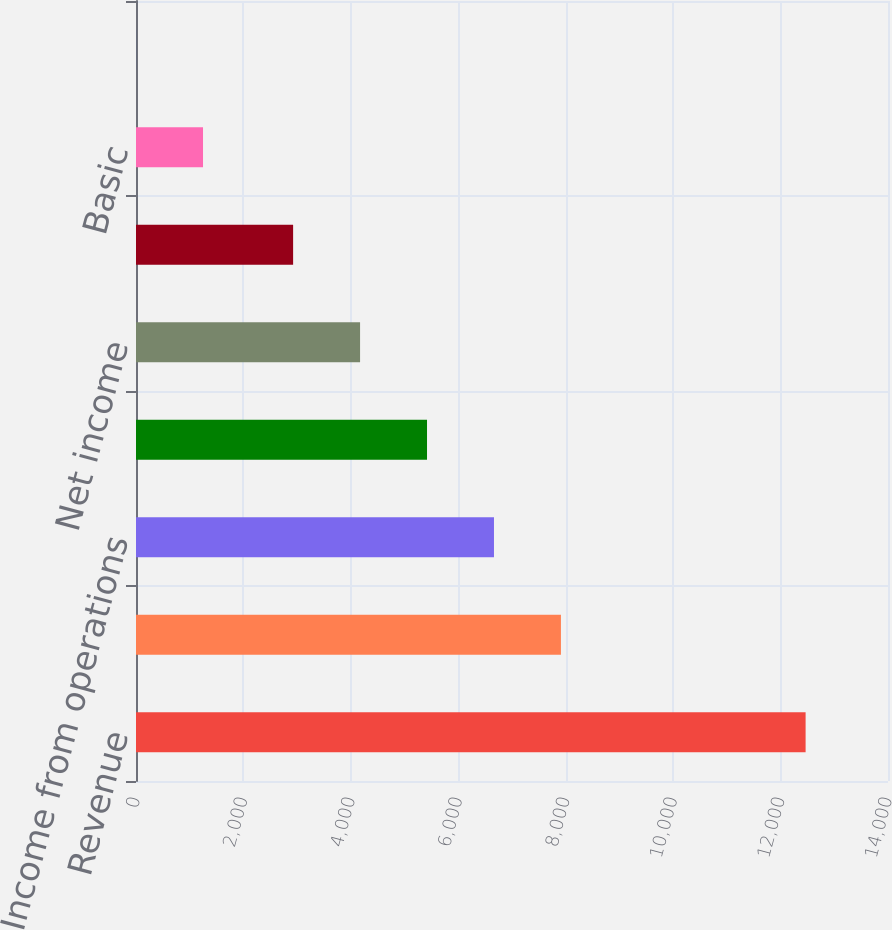Convert chart. <chart><loc_0><loc_0><loc_500><loc_500><bar_chart><fcel>Revenue<fcel>Total costs and expenses (2)<fcel>Income from operations<fcel>Income before provision for<fcel>Net income<fcel>Net income attributable to<fcel>Basic<fcel>Diluted<nl><fcel>12466<fcel>7910.96<fcel>6664.47<fcel>5417.98<fcel>4171.49<fcel>2925<fcel>1247.59<fcel>1.1<nl></chart> 